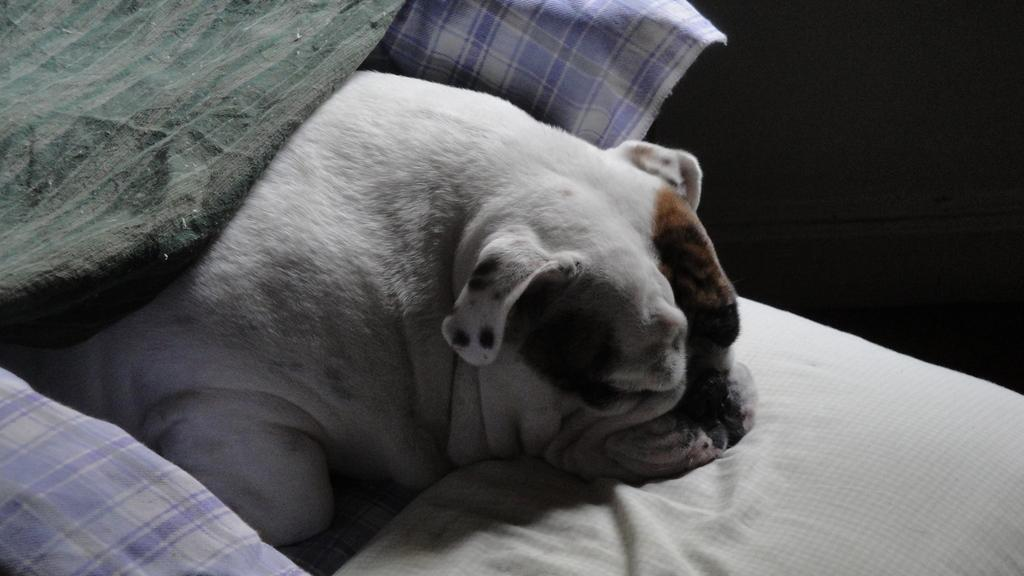What type of animal is present in the image? There is a dog in the image. What is the dog doing in the image? The dog is lying on a surface in the image. Are there any additional items or features related to the dog in the image? Yes, there are clothes on the dog. What type of trucks can be seen in the image? There are no trucks present in the image; it features a dog lying on a surface with clothes on it. What is the dog's voice like in the image? The image is a still photograph, so it does not capture any sound or voice. 